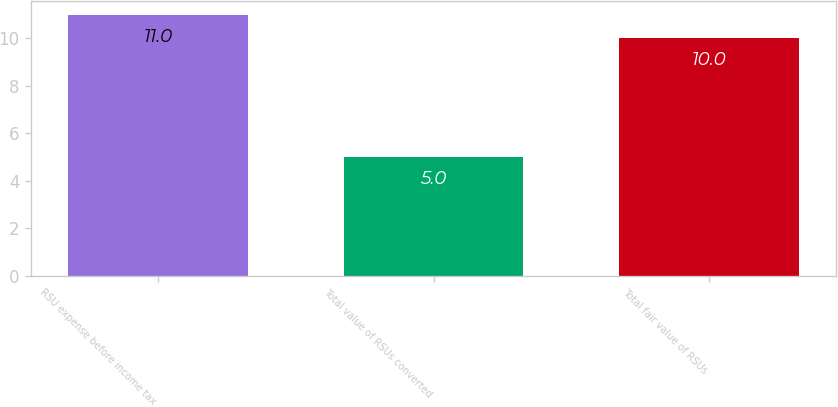<chart> <loc_0><loc_0><loc_500><loc_500><bar_chart><fcel>RSU expense before income tax<fcel>Total value of RSUs converted<fcel>Total fair value of RSUs<nl><fcel>11<fcel>5<fcel>10<nl></chart> 